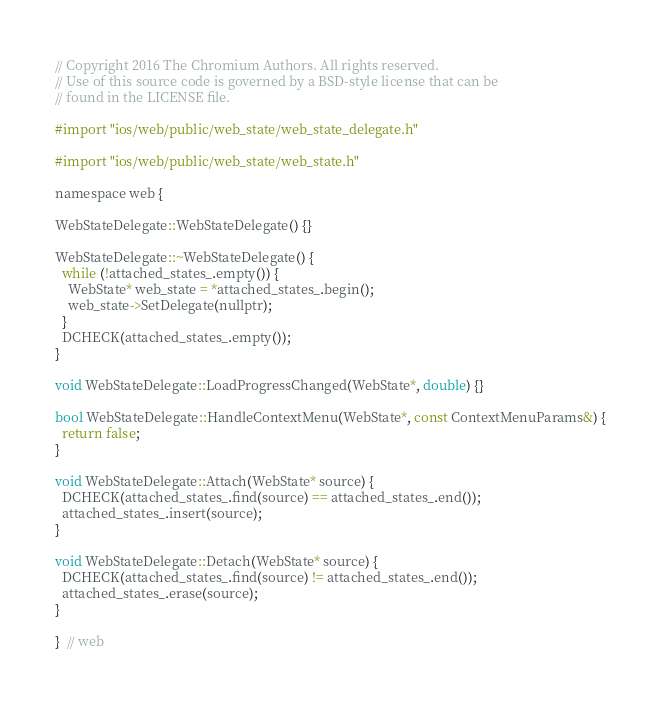Convert code to text. <code><loc_0><loc_0><loc_500><loc_500><_ObjectiveC_>// Copyright 2016 The Chromium Authors. All rights reserved.
// Use of this source code is governed by a BSD-style license that can be
// found in the LICENSE file.

#import "ios/web/public/web_state/web_state_delegate.h"

#import "ios/web/public/web_state/web_state.h"

namespace web {

WebStateDelegate::WebStateDelegate() {}

WebStateDelegate::~WebStateDelegate() {
  while (!attached_states_.empty()) {
    WebState* web_state = *attached_states_.begin();
    web_state->SetDelegate(nullptr);
  }
  DCHECK(attached_states_.empty());
}

void WebStateDelegate::LoadProgressChanged(WebState*, double) {}

bool WebStateDelegate::HandleContextMenu(WebState*, const ContextMenuParams&) {
  return false;
}

void WebStateDelegate::Attach(WebState* source) {
  DCHECK(attached_states_.find(source) == attached_states_.end());
  attached_states_.insert(source);
}

void WebStateDelegate::Detach(WebState* source) {
  DCHECK(attached_states_.find(source) != attached_states_.end());
  attached_states_.erase(source);
}

}  // web
</code> 